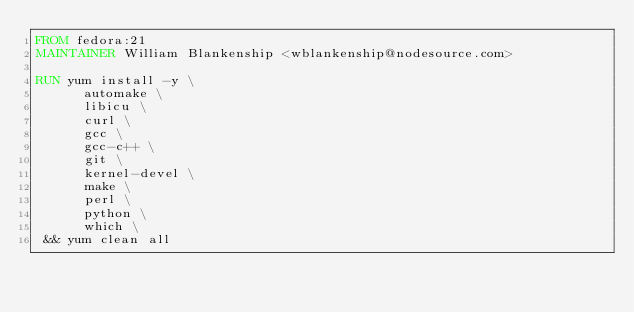<code> <loc_0><loc_0><loc_500><loc_500><_Dockerfile_>FROM fedora:21
MAINTAINER William Blankenship <wblankenship@nodesource.com>

RUN yum install -y \
      automake \
      libicu \
      curl \
      gcc \
      gcc-c++ \
      git \
      kernel-devel \
      make \
      perl \
      python \
      which \
 && yum clean all

</code> 